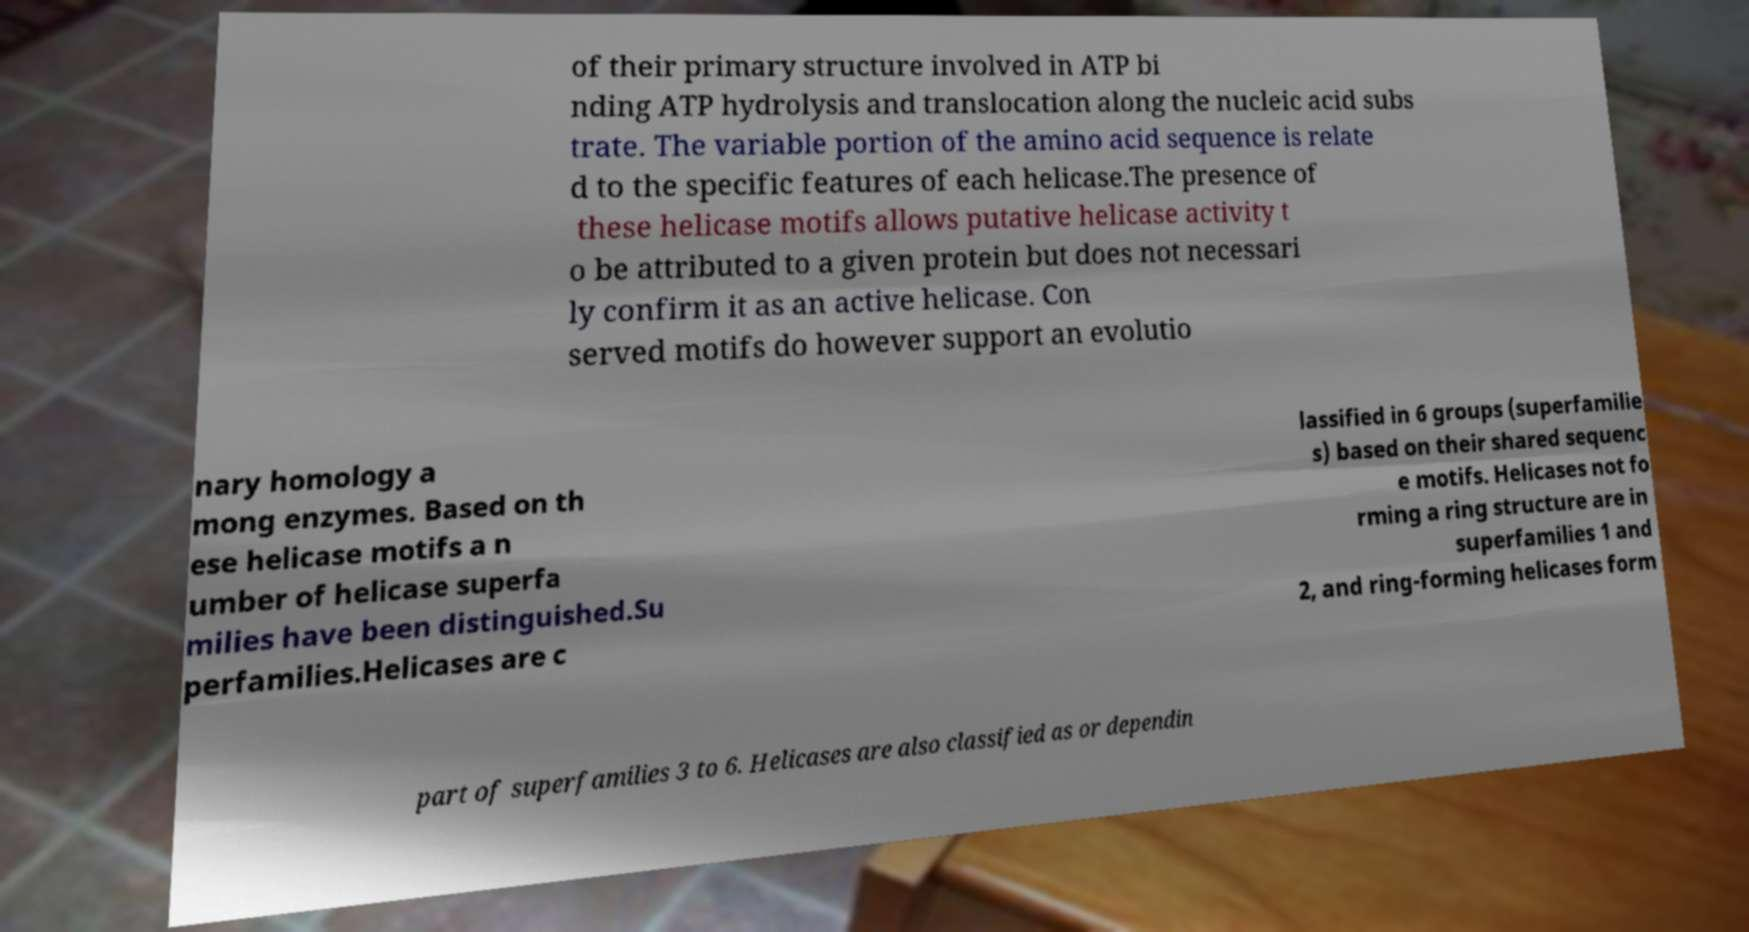Could you extract and type out the text from this image? of their primary structure involved in ATP bi nding ATP hydrolysis and translocation along the nucleic acid subs trate. The variable portion of the amino acid sequence is relate d to the specific features of each helicase.The presence of these helicase motifs allows putative helicase activity t o be attributed to a given protein but does not necessari ly confirm it as an active helicase. Con served motifs do however support an evolutio nary homology a mong enzymes. Based on th ese helicase motifs a n umber of helicase superfa milies have been distinguished.Su perfamilies.Helicases are c lassified in 6 groups (superfamilie s) based on their shared sequenc e motifs. Helicases not fo rming a ring structure are in superfamilies 1 and 2, and ring-forming helicases form part of superfamilies 3 to 6. Helicases are also classified as or dependin 